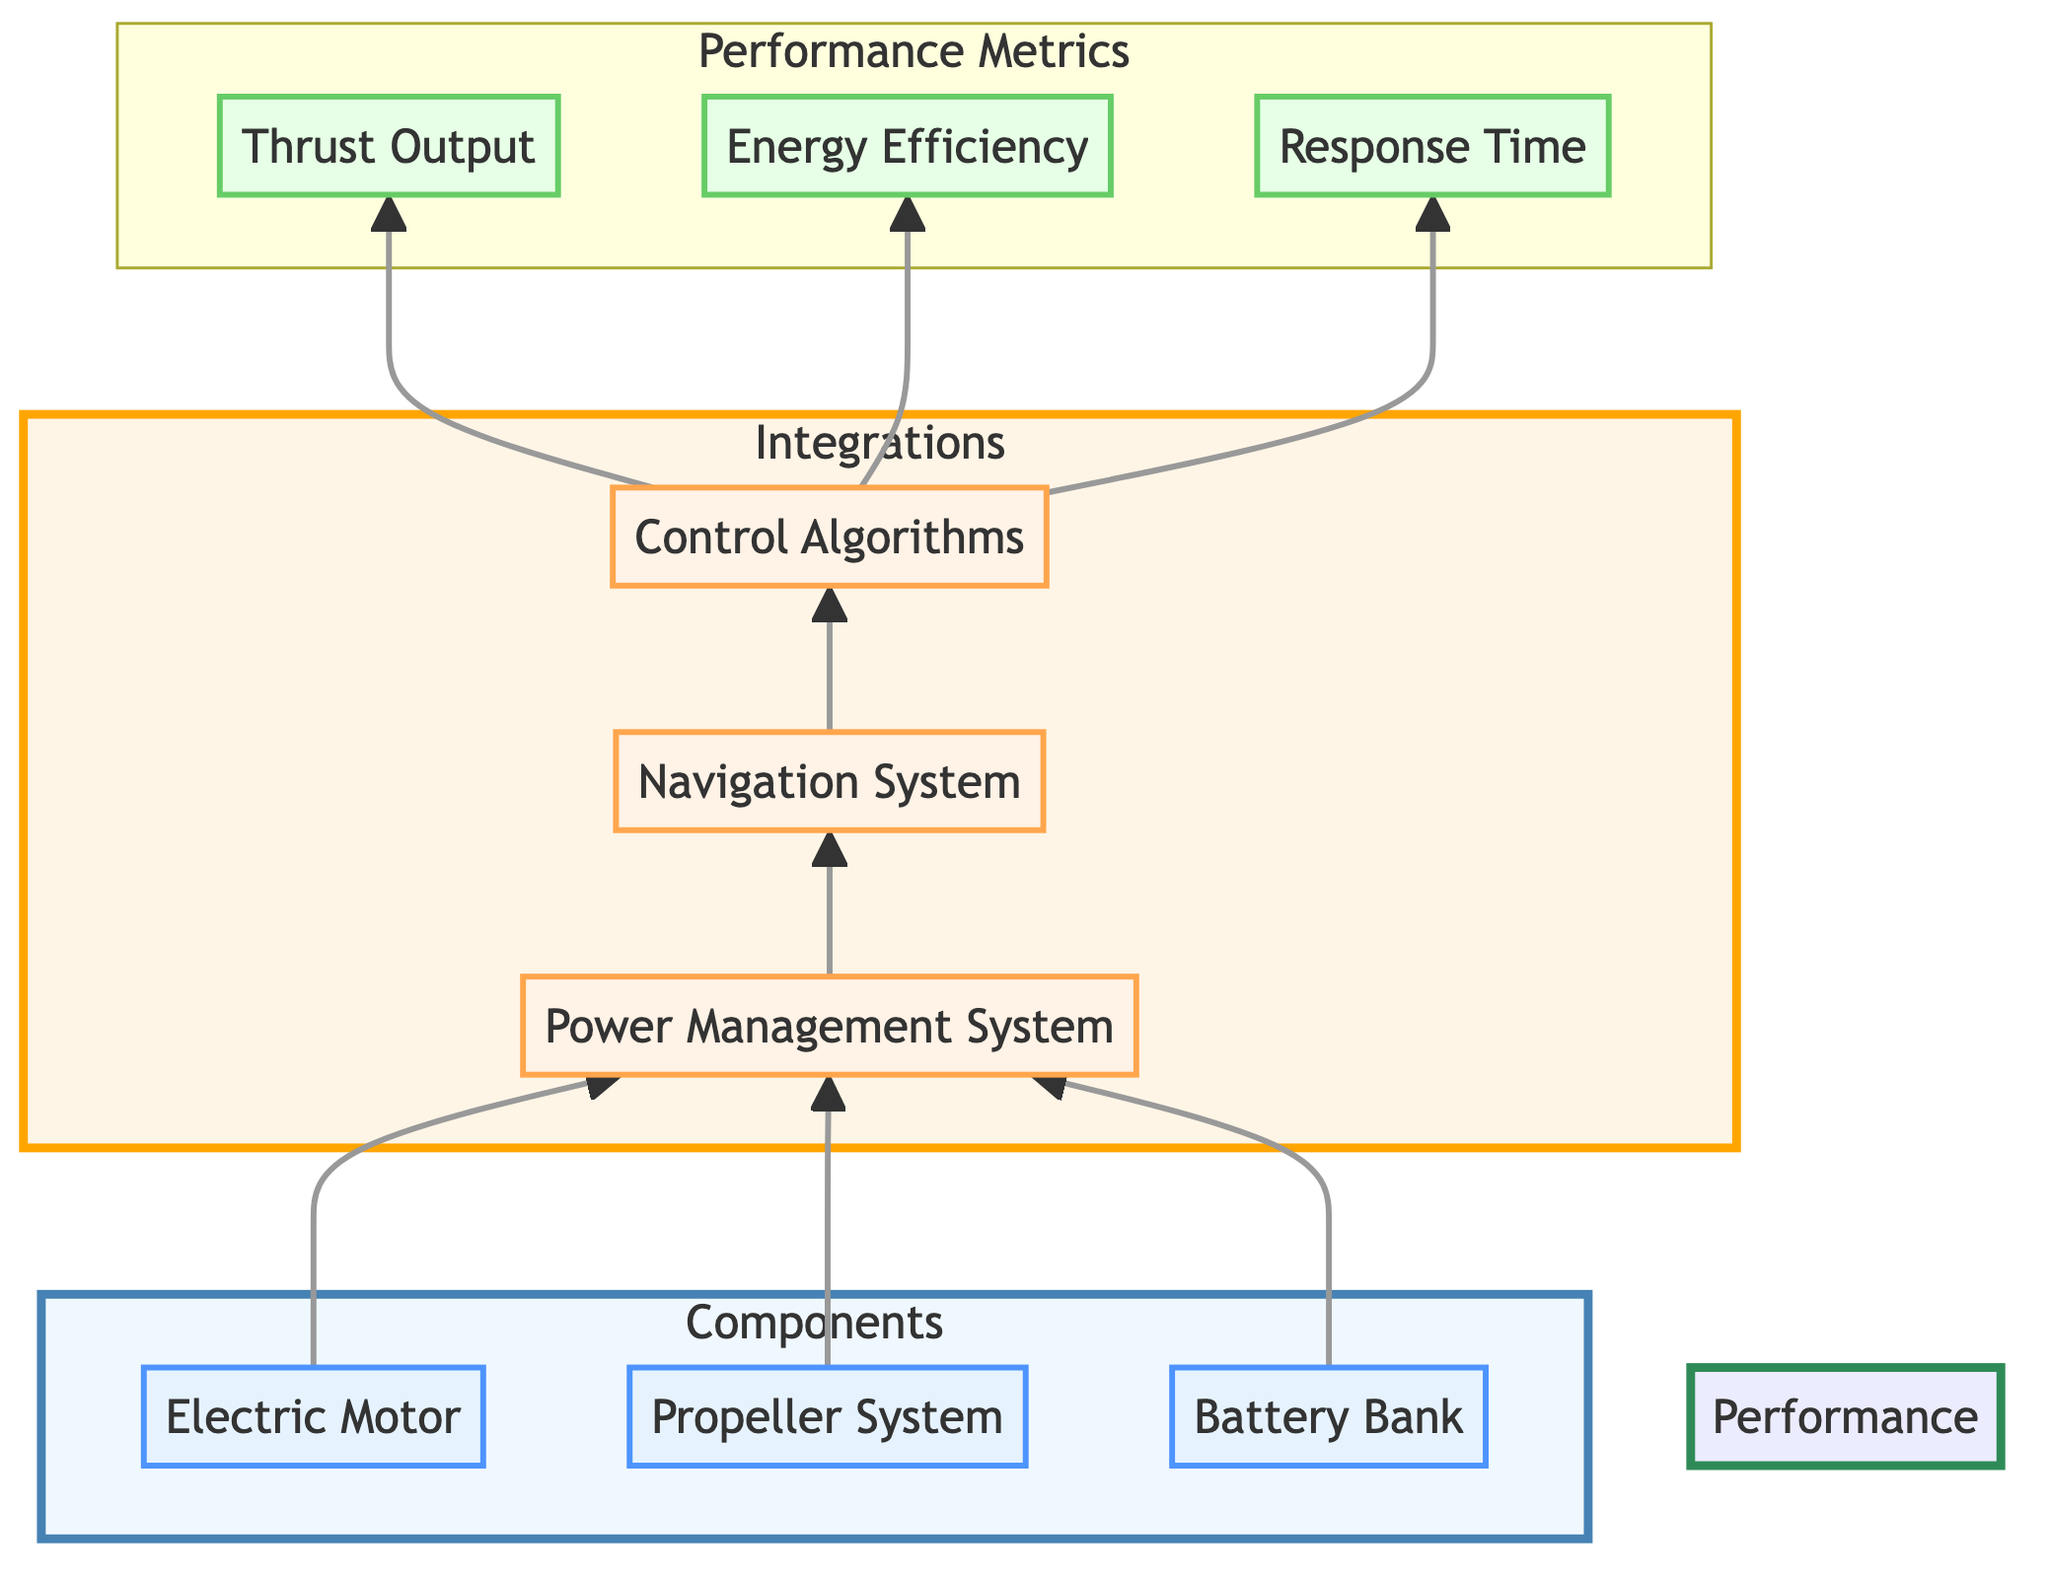What are the three main components of the propulsion system? The diagram lists three main components under the "Components" subgraph: Electric Motor, Propeller System, and Battery Bank.
Answer: Electric Motor, Propeller System, Battery Bank Which integration connects the Battery Bank to the Power Management System? The arrow from the Battery Bank (BB) points directly to the Power Management System (PMS), indicating a connection between these two nodes.
Answer: Power Management System What performance metric is generated from the Control Algorithms? The diagram shows arrows from Control Algorithms (CA) leading to three performance metrics: Thrust Output, Energy Efficiency, and Response Time. Thus, all three metrics are generated from this integration.
Answer: Thrust Output, Energy Efficiency, Response Time How many integrations are there in total? The diagram identifies three integrations in the "Integrations" subgraph: Power Management System, Navigation System, and Control Algorithms, making a total of three integrations.
Answer: Three Which component is linked to both the Power Management System and the Navigation System? The arrow from the Power Management System indicates that both Electric Motor and Propeller System feed into it. The Navigation System is linked to the Power Management System through the same integration. Therefore, the correct answer is the Electric Motor.
Answer: Electric Motor What is the primary role of the Power Management System? Based on the description from the diagram, the Power Management System controls power distribution and energy efficiency among components, which signifies its essential role.
Answer: Controls power distribution and energy efficiency What are the metrics linked to the Control Algorithms? The Control Algorithms connect to three specific performance metrics: Thrust Output, Energy Efficiency, and Response Time, as indicated by arrows leading from the Control Algorithms to these metrics.
Answer: Thrust Output, Energy Efficiency, Response Time Which component has the most direct contribution to thrust? The diagram indicates that the Propeller System is the component responsible for generating thrust, as it directly relates to thrust through the control of the Power Management System.
Answer: Propeller System How is Energy Efficiency measured in the system? Energy Efficiency is defined in the diagram as the ratio of used energy to total energy available, being an important metric for performance evaluation. It specifically relates to the overall energy management of the propulsion system.
Answer: Ratio of used energy to total energy available 